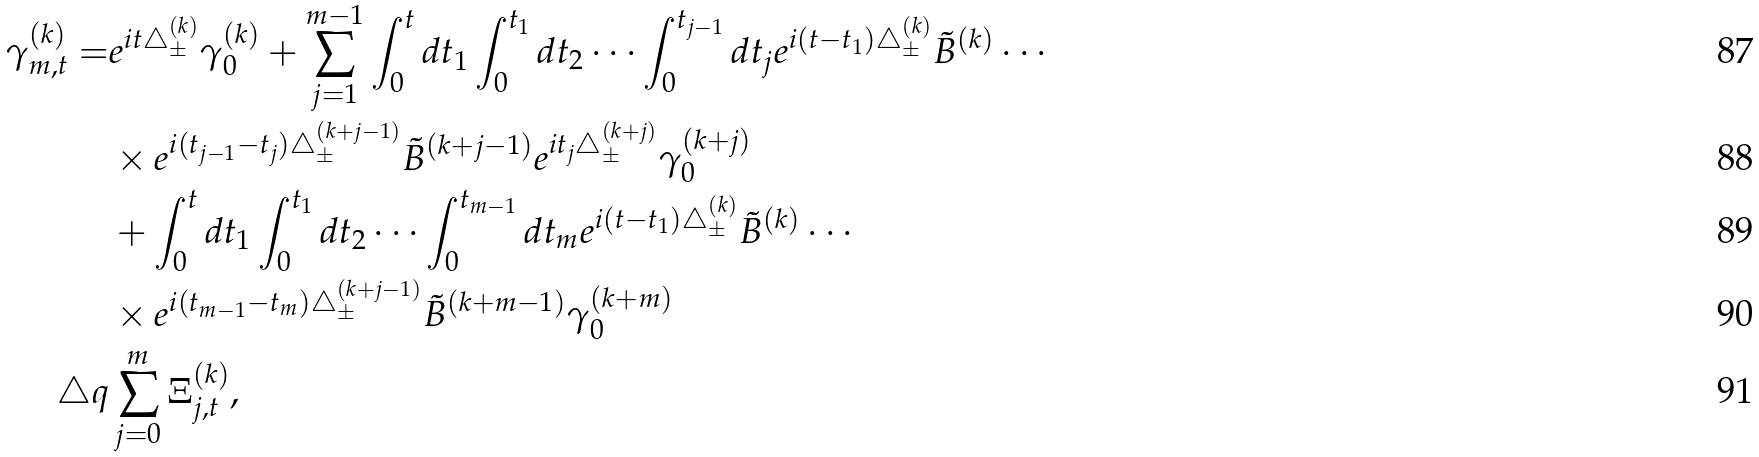Convert formula to latex. <formula><loc_0><loc_0><loc_500><loc_500>\gamma ^ { ( k ) } _ { m , t } = & e ^ { i t \triangle ^ { ( k ) } _ { \pm } } \gamma ^ { ( k ) } _ { 0 } + \sum _ { j = 1 } ^ { m - 1 } \int _ { 0 } ^ { t } d t _ { 1 } \int _ { 0 } ^ { t _ { 1 } } d t _ { 2 } \cdots \int _ { 0 } ^ { t _ { j - 1 } } d t _ { j } e ^ { i ( t - t _ { 1 } ) \triangle ^ { ( k ) } _ { \pm } } \tilde { B } ^ { ( k ) } \cdots \\ & \times e ^ { i ( t _ { j - 1 } - t _ { j } ) \triangle ^ { ( k + j - 1 ) } _ { \pm } } \tilde { B } ^ { ( k + j - 1 ) } e ^ { i t _ { j } \triangle ^ { ( k + j ) } _ { \pm } } \gamma ^ { ( k + j ) } _ { 0 } \\ & + \int _ { 0 } ^ { t } d t _ { 1 } \int _ { 0 } ^ { t _ { 1 } } d t _ { 2 } \cdots \int _ { 0 } ^ { t _ { m - 1 } } d t _ { m } e ^ { i ( t - t _ { 1 } ) \triangle ^ { ( k ) } _ { \pm } } \tilde { B } ^ { ( k ) } \cdots \\ & \times e ^ { i ( t _ { m - 1 } - t _ { m } ) \triangle ^ { ( k + j - 1 ) } _ { \pm } } \tilde { B } ^ { ( k + m - 1 ) } \gamma ^ { ( k + m ) } _ { 0 } \\ \triangle q & \sum _ { j = 0 } ^ { m } \Xi _ { j , t } ^ { ( k ) } ,</formula> 